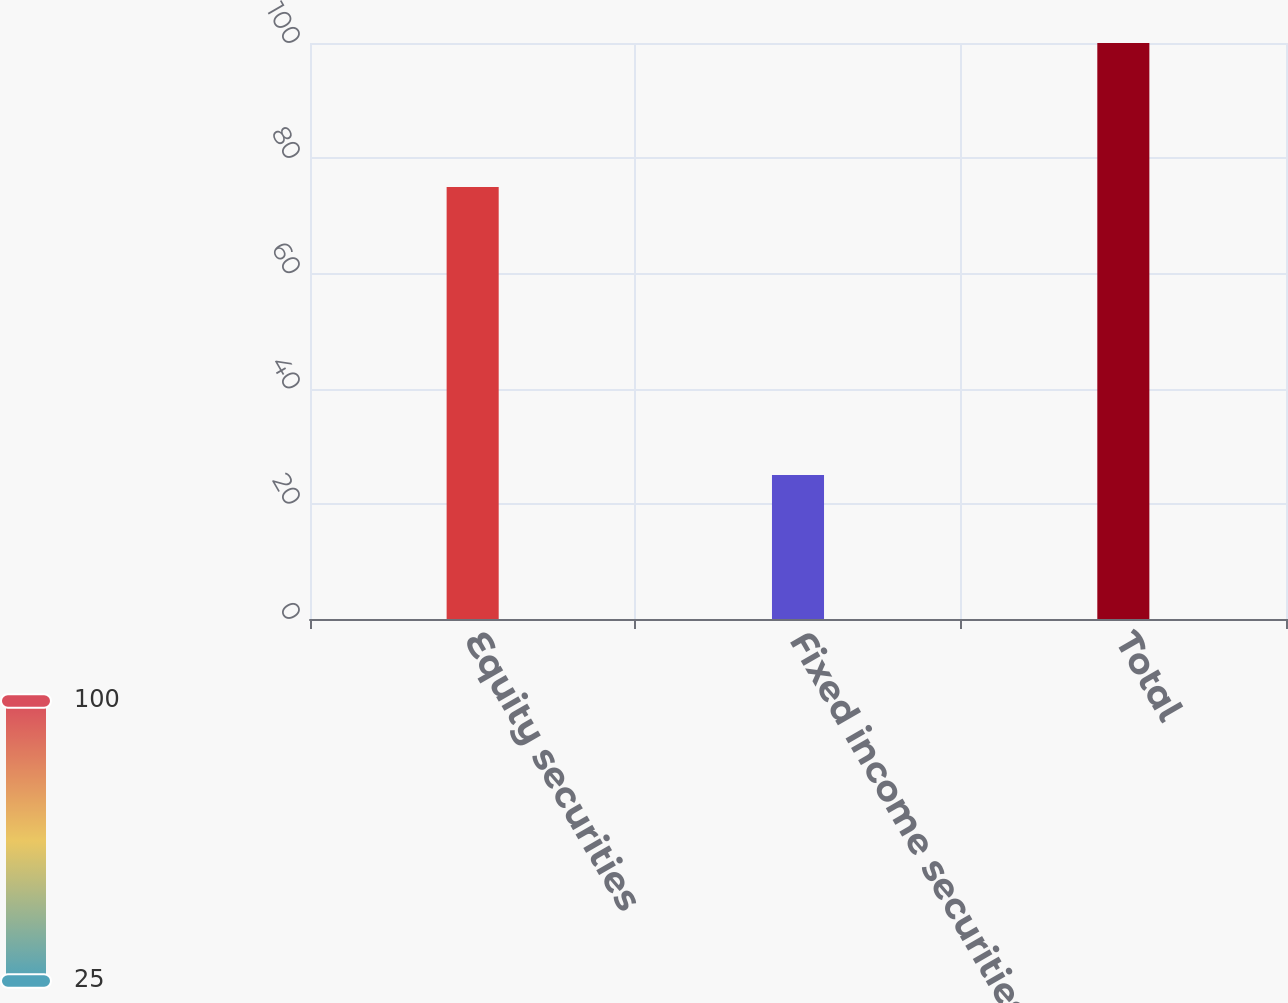<chart> <loc_0><loc_0><loc_500><loc_500><bar_chart><fcel>Equity securities<fcel>Fixed income securities<fcel>Total<nl><fcel>75<fcel>25<fcel>100<nl></chart> 